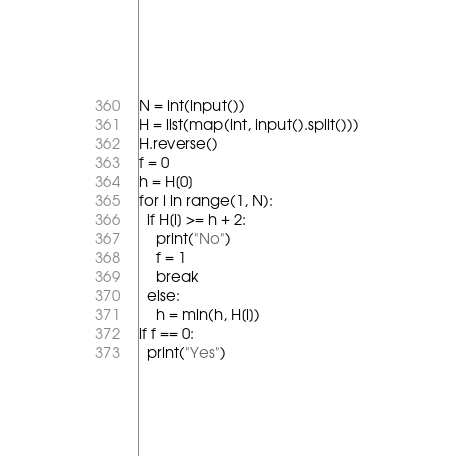<code> <loc_0><loc_0><loc_500><loc_500><_Python_>N = int(input())
H = list(map(int, input().split()))
H.reverse()
f = 0
h = H[0]
for i in range(1, N):
  if H[i] >= h + 2:
    print("No")
    f = 1
    break
  else:
    h = min(h, H[i])
if f == 0:
  print("Yes")</code> 